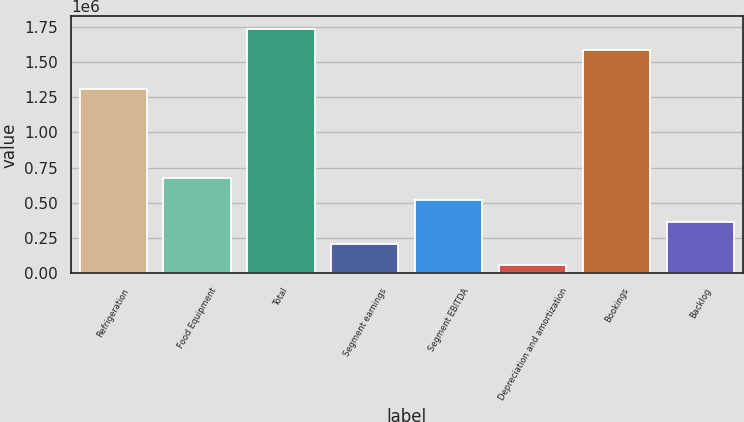Convert chart. <chart><loc_0><loc_0><loc_500><loc_500><bar_chart><fcel>Refrigeration<fcel>Food Equipment<fcel>Total<fcel>Segment earnings<fcel>Segment EBITDA<fcel>Depreciation and amortization<fcel>Bookings<fcel>Backlog<nl><fcel>1.30553e+06<fcel>673966<fcel>1.7368e+06<fcel>211397<fcel>519776<fcel>57207<fcel>1.58261e+06<fcel>365587<nl></chart> 